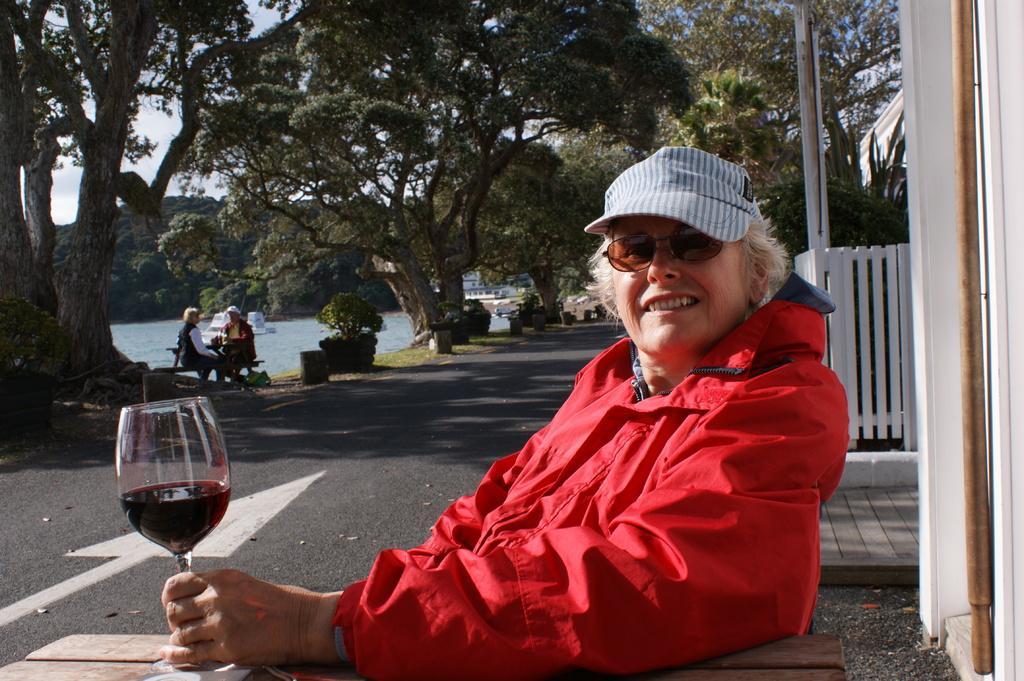Could you give a brief overview of what you see in this image? This image is clicked outside. There are trees on the top and left side and right side. There is water in the middle and there is one table and chairs. Two people are sitting there. There are benches in the middle. In the front there is a chair and table ,a person with red jacket and goggles is sitting on the chair. She is also wearing a cap. She is holding a glass. 